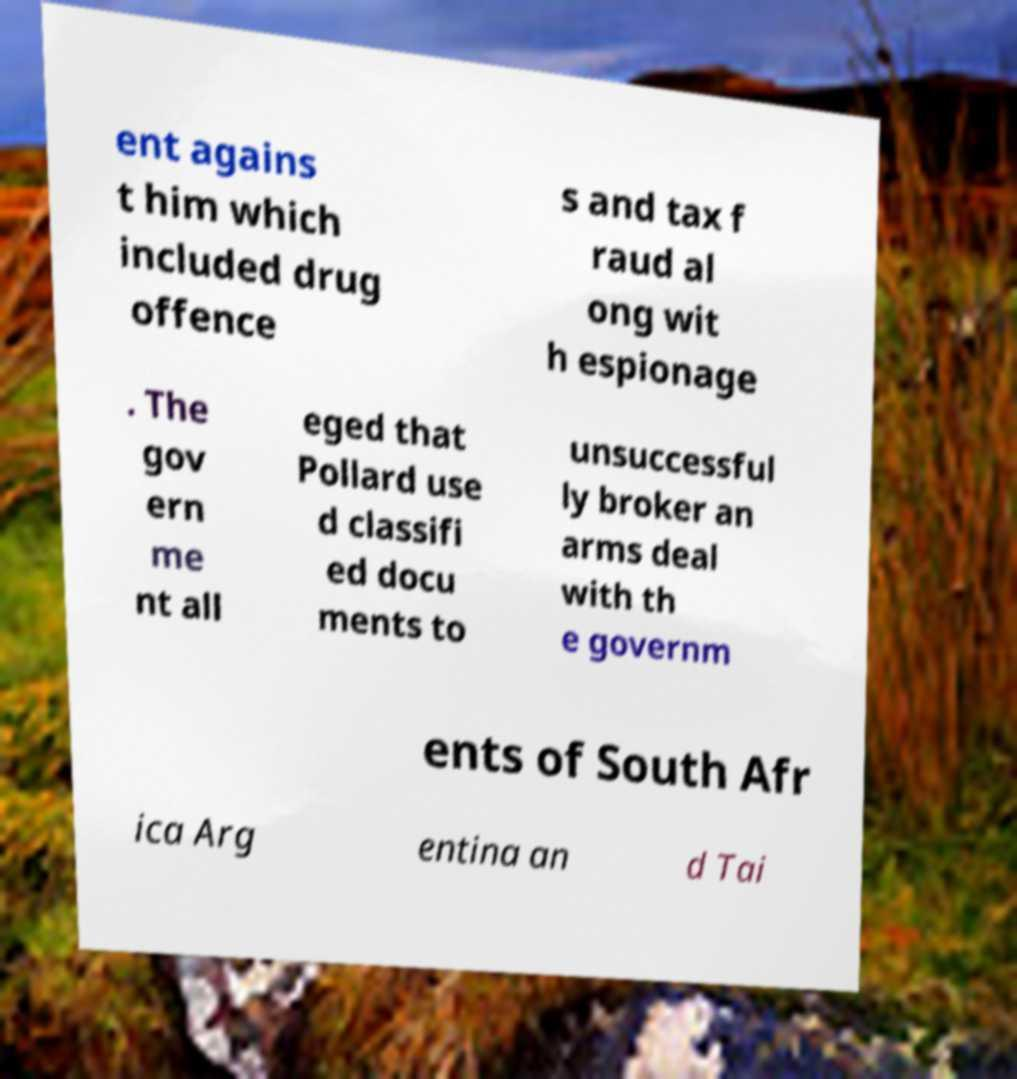Could you assist in decoding the text presented in this image and type it out clearly? ent agains t him which included drug offence s and tax f raud al ong wit h espionage . The gov ern me nt all eged that Pollard use d classifi ed docu ments to unsuccessful ly broker an arms deal with th e governm ents of South Afr ica Arg entina an d Tai 